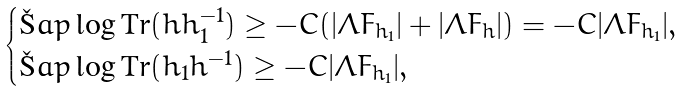<formula> <loc_0><loc_0><loc_500><loc_500>\begin{cases} \L a p \log \text {Tr} ( h h _ { 1 } ^ { - 1 } ) \geq - C ( | \Lambda F _ { h _ { 1 } } | + | \Lambda F _ { h } | ) = - C | \Lambda F _ { h _ { 1 } } | , \\ \L a p \log \text {Tr} ( h _ { 1 } h ^ { - 1 } ) \geq - C | \Lambda F _ { h _ { 1 } } | , \end{cases}</formula> 